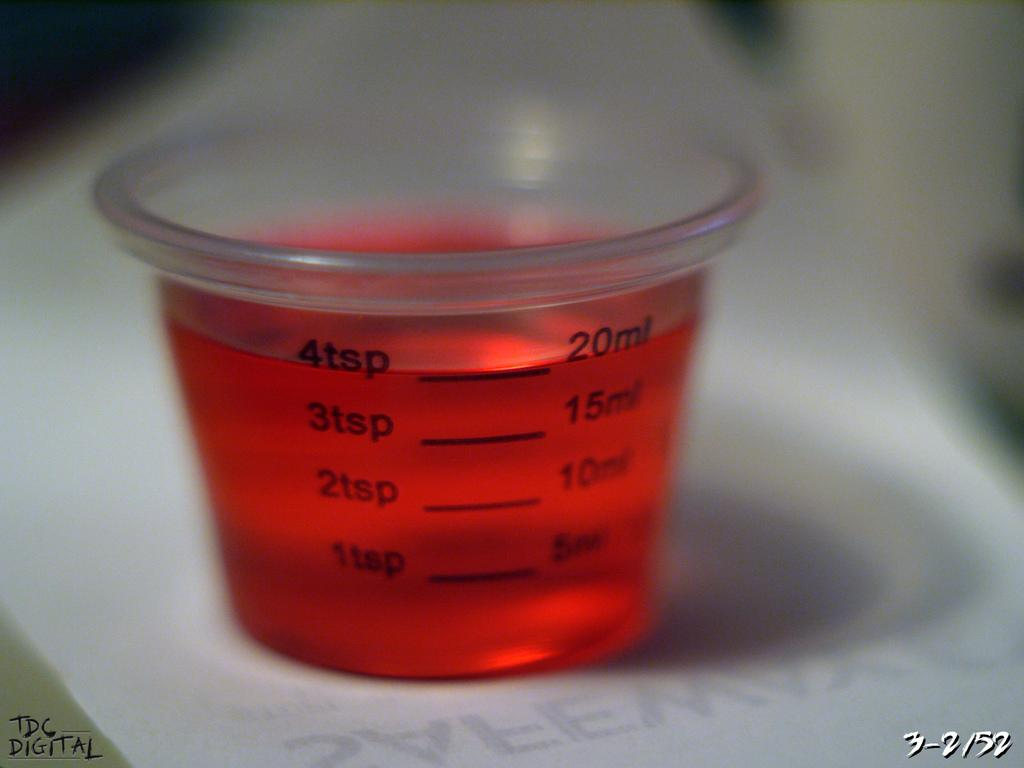Provide a one-sentence caption for the provided image. The medicine cup contains 4 teaspoons of red syrup. 